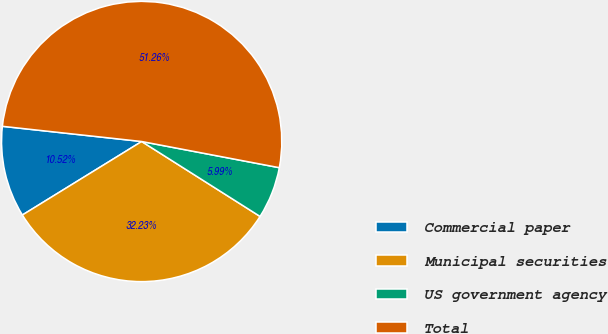Convert chart. <chart><loc_0><loc_0><loc_500><loc_500><pie_chart><fcel>Commercial paper<fcel>Municipal securities<fcel>US government agency<fcel>Total<nl><fcel>10.52%<fcel>32.23%<fcel>5.99%<fcel>51.26%<nl></chart> 